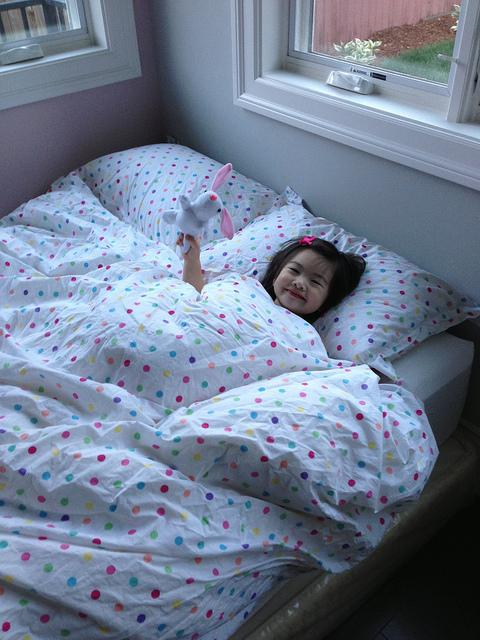Who is in the bed? Please explain your reasoning. little girl. She is young and holding a stuffed bunny. 